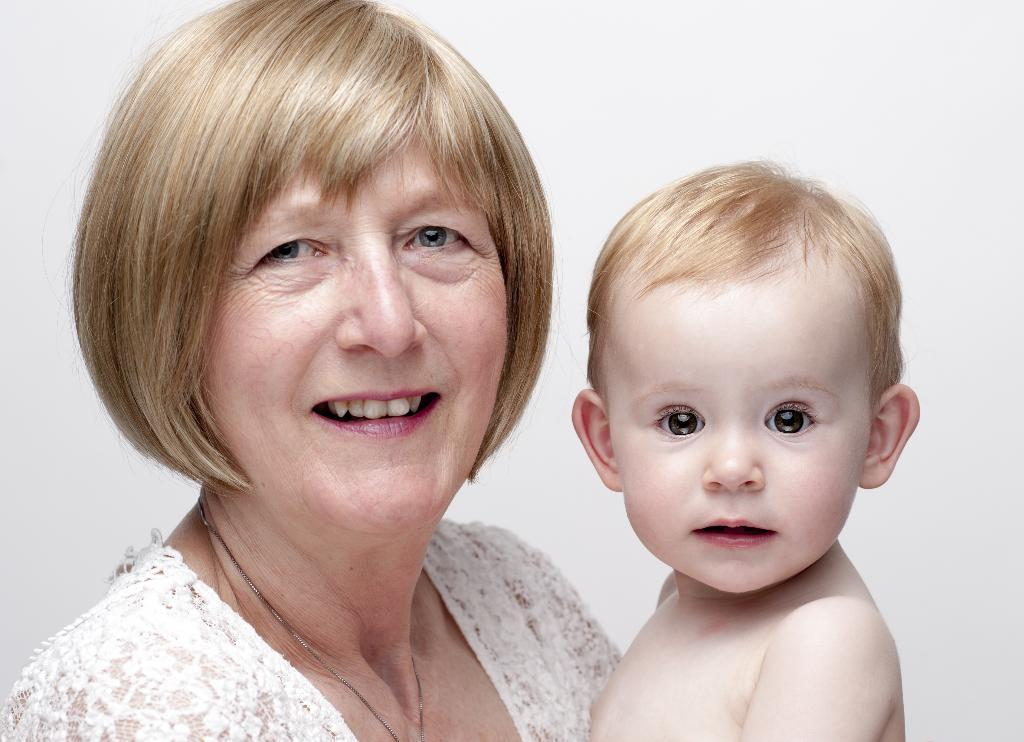What is the main subject of the image? The main subject of the image is a woman. What is the woman doing in the image? The woman is standing and holding a kid. What can be seen in the background of the image? The background of the image is white. What type of rhythm can be heard in the background of the image? There is no audible rhythm present in the image, as it is a still photograph. What type of scissors is the woman using to cut the kid's hair in the image? There is no indication in the image that the woman is cutting the kid's hair or using scissors. --- Facts: 1. There is a car in the image. 2. The car is red. 3. The car has four wheels. 4. There are people in the car. 5. The car is parked on the street. Absurd Topics: parrot, sandcastle, volcano Conversation: What is the main subject of the image? The main subject of the image is a car. What color is the car? The car is red. How many wheels does the car have? The car has four wheels. What is the car's current status in the image? The car is parked on the street. Reasoning: Let's think step by step in order to produce the conversation. We start by identifying the main subject of the image, which is the car. Next, we describe the specific features of the car, such as its color and the number of wheels. Then, we observe the car's current status, noting that it is parked on the street. Absurd Question/Answer: Can you tell me how many parrots are sitting on the roof of the car in the image? There are no parrots present on the roof of the car in the image. What type of sandcastle is visible in the background of the image? There is no sandcastle visible in the background of the image. 